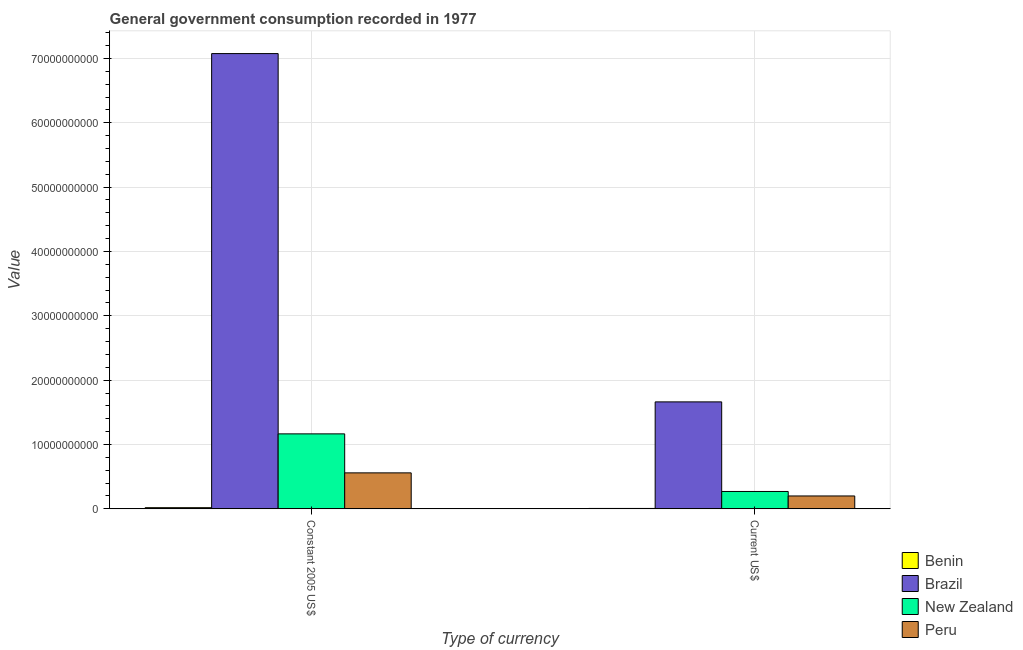How many different coloured bars are there?
Offer a terse response. 4. How many groups of bars are there?
Offer a very short reply. 2. Are the number of bars on each tick of the X-axis equal?
Provide a succinct answer. Yes. What is the label of the 1st group of bars from the left?
Offer a terse response. Constant 2005 US$. What is the value consumed in constant 2005 us$ in Brazil?
Provide a short and direct response. 7.08e+1. Across all countries, what is the maximum value consumed in current us$?
Ensure brevity in your answer.  1.66e+1. Across all countries, what is the minimum value consumed in current us$?
Provide a short and direct response. 6.23e+07. In which country was the value consumed in current us$ minimum?
Your answer should be very brief. Benin. What is the total value consumed in current us$ in the graph?
Your response must be concise. 2.14e+1. What is the difference between the value consumed in constant 2005 us$ in New Zealand and that in Peru?
Make the answer very short. 6.06e+09. What is the difference between the value consumed in constant 2005 us$ in New Zealand and the value consumed in current us$ in Brazil?
Keep it short and to the point. -4.97e+09. What is the average value consumed in constant 2005 us$ per country?
Offer a very short reply. 2.20e+1. What is the difference between the value consumed in constant 2005 us$ and value consumed in current us$ in Benin?
Provide a succinct answer. 1.19e+08. What is the ratio of the value consumed in current us$ in New Zealand to that in Benin?
Your answer should be very brief. 43.3. Is the value consumed in current us$ in Brazil less than that in Peru?
Give a very brief answer. No. What does the 1st bar from the left in Constant 2005 US$ represents?
Make the answer very short. Benin. What does the 3rd bar from the right in Current US$ represents?
Your answer should be very brief. Brazil. How many bars are there?
Your answer should be very brief. 8. Does the graph contain grids?
Ensure brevity in your answer.  Yes. What is the title of the graph?
Provide a succinct answer. General government consumption recorded in 1977. Does "Haiti" appear as one of the legend labels in the graph?
Ensure brevity in your answer.  No. What is the label or title of the X-axis?
Keep it short and to the point. Type of currency. What is the label or title of the Y-axis?
Your response must be concise. Value. What is the Value in Benin in Constant 2005 US$?
Offer a very short reply. 1.81e+08. What is the Value of Brazil in Constant 2005 US$?
Keep it short and to the point. 7.08e+1. What is the Value of New Zealand in Constant 2005 US$?
Make the answer very short. 1.17e+1. What is the Value in Peru in Constant 2005 US$?
Provide a short and direct response. 5.59e+09. What is the Value of Benin in Current US$?
Provide a succinct answer. 6.23e+07. What is the Value of Brazil in Current US$?
Offer a terse response. 1.66e+1. What is the Value of New Zealand in Current US$?
Your response must be concise. 2.70e+09. What is the Value in Peru in Current US$?
Your answer should be very brief. 2.00e+09. Across all Type of currency, what is the maximum Value in Benin?
Give a very brief answer. 1.81e+08. Across all Type of currency, what is the maximum Value in Brazil?
Provide a succinct answer. 7.08e+1. Across all Type of currency, what is the maximum Value of New Zealand?
Give a very brief answer. 1.17e+1. Across all Type of currency, what is the maximum Value of Peru?
Your answer should be very brief. 5.59e+09. Across all Type of currency, what is the minimum Value of Benin?
Your response must be concise. 6.23e+07. Across all Type of currency, what is the minimum Value in Brazil?
Make the answer very short. 1.66e+1. Across all Type of currency, what is the minimum Value of New Zealand?
Offer a terse response. 2.70e+09. Across all Type of currency, what is the minimum Value of Peru?
Offer a very short reply. 2.00e+09. What is the total Value of Benin in the graph?
Provide a succinct answer. 2.44e+08. What is the total Value in Brazil in the graph?
Your answer should be very brief. 8.74e+1. What is the total Value in New Zealand in the graph?
Provide a short and direct response. 1.44e+1. What is the total Value of Peru in the graph?
Offer a very short reply. 7.59e+09. What is the difference between the Value in Benin in Constant 2005 US$ and that in Current US$?
Ensure brevity in your answer.  1.19e+08. What is the difference between the Value of Brazil in Constant 2005 US$ and that in Current US$?
Your answer should be compact. 5.41e+1. What is the difference between the Value in New Zealand in Constant 2005 US$ and that in Current US$?
Ensure brevity in your answer.  8.95e+09. What is the difference between the Value of Peru in Constant 2005 US$ and that in Current US$?
Your answer should be very brief. 3.59e+09. What is the difference between the Value in Benin in Constant 2005 US$ and the Value in Brazil in Current US$?
Make the answer very short. -1.64e+1. What is the difference between the Value of Benin in Constant 2005 US$ and the Value of New Zealand in Current US$?
Ensure brevity in your answer.  -2.52e+09. What is the difference between the Value of Benin in Constant 2005 US$ and the Value of Peru in Current US$?
Your answer should be very brief. -1.82e+09. What is the difference between the Value in Brazil in Constant 2005 US$ and the Value in New Zealand in Current US$?
Offer a very short reply. 6.81e+1. What is the difference between the Value of Brazil in Constant 2005 US$ and the Value of Peru in Current US$?
Make the answer very short. 6.87e+1. What is the difference between the Value of New Zealand in Constant 2005 US$ and the Value of Peru in Current US$?
Make the answer very short. 9.65e+09. What is the average Value in Benin per Type of currency?
Your answer should be compact. 1.22e+08. What is the average Value of Brazil per Type of currency?
Make the answer very short. 4.37e+1. What is the average Value in New Zealand per Type of currency?
Your response must be concise. 7.18e+09. What is the average Value of Peru per Type of currency?
Your answer should be very brief. 3.80e+09. What is the difference between the Value of Benin and Value of Brazil in Constant 2005 US$?
Your answer should be compact. -7.06e+1. What is the difference between the Value in Benin and Value in New Zealand in Constant 2005 US$?
Provide a succinct answer. -1.15e+1. What is the difference between the Value in Benin and Value in Peru in Constant 2005 US$?
Offer a very short reply. -5.41e+09. What is the difference between the Value of Brazil and Value of New Zealand in Constant 2005 US$?
Provide a succinct answer. 5.91e+1. What is the difference between the Value of Brazil and Value of Peru in Constant 2005 US$?
Make the answer very short. 6.52e+1. What is the difference between the Value of New Zealand and Value of Peru in Constant 2005 US$?
Provide a short and direct response. 6.06e+09. What is the difference between the Value of Benin and Value of Brazil in Current US$?
Your answer should be compact. -1.66e+1. What is the difference between the Value of Benin and Value of New Zealand in Current US$?
Provide a succinct answer. -2.64e+09. What is the difference between the Value in Benin and Value in Peru in Current US$?
Provide a short and direct response. -1.94e+09. What is the difference between the Value in Brazil and Value in New Zealand in Current US$?
Give a very brief answer. 1.39e+1. What is the difference between the Value in Brazil and Value in Peru in Current US$?
Ensure brevity in your answer.  1.46e+1. What is the difference between the Value of New Zealand and Value of Peru in Current US$?
Provide a succinct answer. 6.95e+08. What is the ratio of the Value of Benin in Constant 2005 US$ to that in Current US$?
Make the answer very short. 2.91. What is the ratio of the Value in Brazil in Constant 2005 US$ to that in Current US$?
Offer a very short reply. 4.26. What is the ratio of the Value in New Zealand in Constant 2005 US$ to that in Current US$?
Ensure brevity in your answer.  4.32. What is the ratio of the Value of Peru in Constant 2005 US$ to that in Current US$?
Keep it short and to the point. 2.79. What is the difference between the highest and the second highest Value of Benin?
Ensure brevity in your answer.  1.19e+08. What is the difference between the highest and the second highest Value of Brazil?
Ensure brevity in your answer.  5.41e+1. What is the difference between the highest and the second highest Value in New Zealand?
Your answer should be compact. 8.95e+09. What is the difference between the highest and the second highest Value of Peru?
Make the answer very short. 3.59e+09. What is the difference between the highest and the lowest Value in Benin?
Ensure brevity in your answer.  1.19e+08. What is the difference between the highest and the lowest Value of Brazil?
Offer a terse response. 5.41e+1. What is the difference between the highest and the lowest Value of New Zealand?
Offer a terse response. 8.95e+09. What is the difference between the highest and the lowest Value in Peru?
Provide a succinct answer. 3.59e+09. 